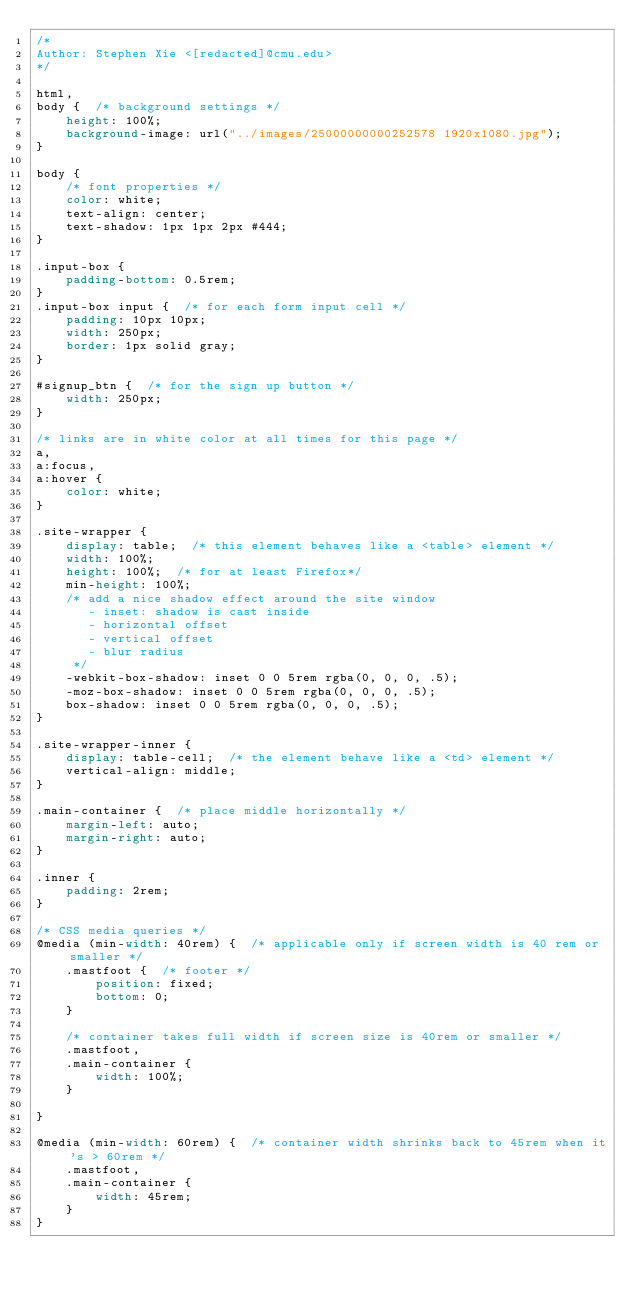<code> <loc_0><loc_0><loc_500><loc_500><_CSS_>/*
Author: Stephen Xie <[redacted]@cmu.edu>
*/

html,
body {  /* background settings */
    height: 100%;
    background-image: url("../images/25000000000252578 1920x1080.jpg");
}

body {
    /* font properties */
    color: white;
    text-align: center;
    text-shadow: 1px 1px 2px #444;
}

.input-box {
    padding-bottom: 0.5rem;
}
.input-box input {  /* for each form input cell */
    padding: 10px 10px;
    width: 250px;
    border: 1px solid gray;
}

#signup_btn {  /* for the sign up button */
    width: 250px;
}

/* links are in white color at all times for this page */
a,
a:focus,
a:hover {
    color: white;
}

.site-wrapper {
    display: table;  /* this element behaves like a <table> element */
    width: 100%;
    height: 100%;  /* for at least Firefox*/
    min-height: 100%;
    /* add a nice shadow effect around the site window
       - inset: shadow is cast inside
       - horizontal offset
       - vertical offset
       - blur radius
     */
    -webkit-box-shadow: inset 0 0 5rem rgba(0, 0, 0, .5);
    -moz-box-shadow: inset 0 0 5rem rgba(0, 0, 0, .5);
    box-shadow: inset 0 0 5rem rgba(0, 0, 0, .5);
}

.site-wrapper-inner {
    display: table-cell;  /* the element behave like a <td> element */
    vertical-align: middle;
}

.main-container {  /* place middle horizontally */
    margin-left: auto;
    margin-right: auto;
}

.inner {
    padding: 2rem;
}

/* CSS media queries */
@media (min-width: 40rem) {  /* applicable only if screen width is 40 rem or smaller */
    .mastfoot {  /* footer */
        position: fixed;
        bottom: 0;
    }

    /* container takes full width if screen size is 40rem or smaller */
    .mastfoot,
    .main-container {
        width: 100%;
    }

}

@media (min-width: 60rem) {  /* container width shrinks back to 45rem when it's > 60rem */
    .mastfoot,
    .main-container {
        width: 45rem;
    }
}
</code> 